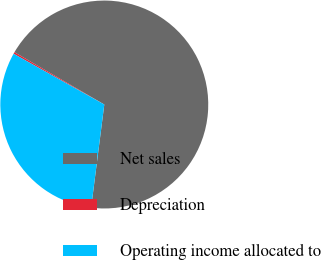<chart> <loc_0><loc_0><loc_500><loc_500><pie_chart><fcel>Net sales<fcel>Depreciation<fcel>Operating income allocated to<nl><fcel>68.63%<fcel>0.27%<fcel>31.1%<nl></chart> 